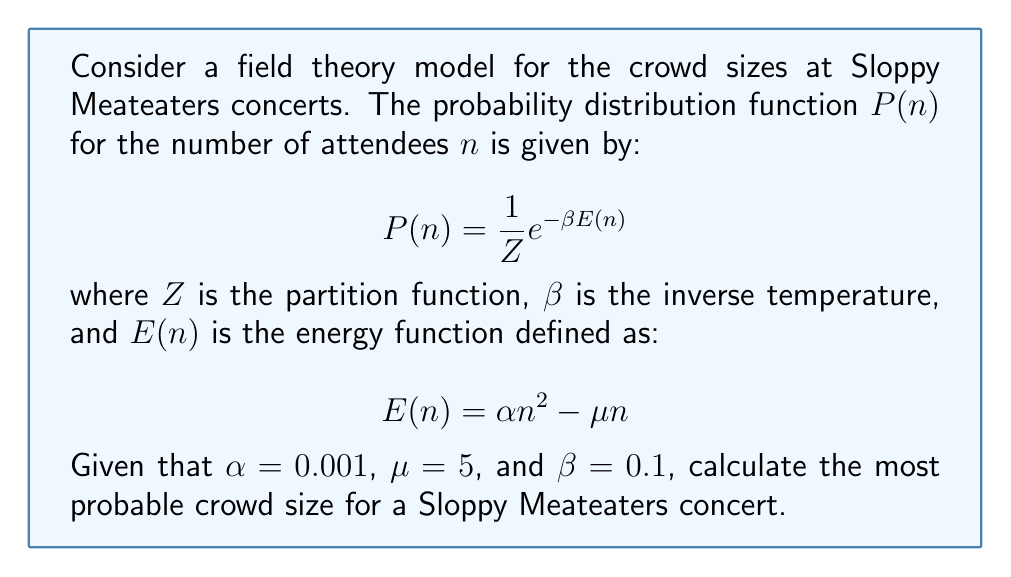Can you answer this question? To find the most probable crowd size, we need to maximize the probability distribution function $P(n)$. This is equivalent to minimizing the energy function $E(n)$, as $P(n)$ is exponentially related to $-\beta E(n)$.

Step 1: Express the energy function $E(n)$:
$$E(n) = 0.001n^2 - 5n$$

Step 2: To find the minimum of $E(n)$, we differentiate it with respect to $n$ and set it to zero:
$$\frac{dE}{dn} = 2(0.001)n - 5 = 0$$

Step 3: Solve for $n$:
$$2(0.001)n = 5$$
$$0.002n = 5$$
$$n = \frac{5}{0.002} = 2500$$

Step 4: Verify that this is indeed a minimum by checking the second derivative:
$$\frac{d^2E}{dn^2} = 2(0.001) > 0$$

Since the second derivative is positive, we confirm that $n = 2500$ gives a minimum of $E(n)$ and thus a maximum of $P(n)$.

Therefore, the most probable crowd size for a Sloppy Meateaters concert under these conditions is 2500 attendees.
Answer: 2500 attendees 